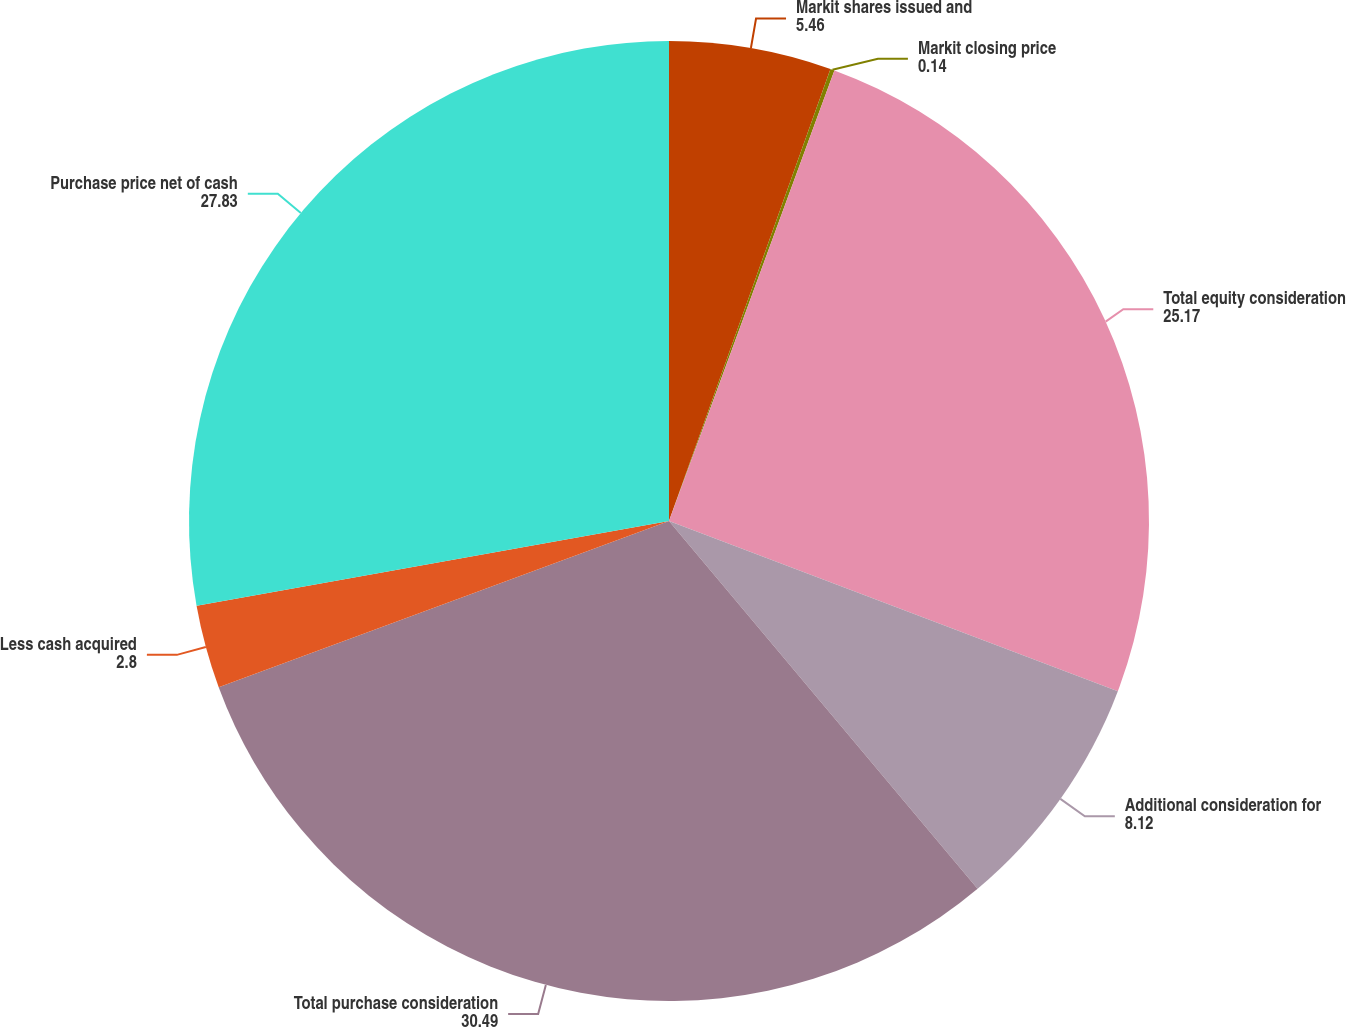Convert chart to OTSL. <chart><loc_0><loc_0><loc_500><loc_500><pie_chart><fcel>Markit shares issued and<fcel>Markit closing price<fcel>Total equity consideration<fcel>Additional consideration for<fcel>Total purchase consideration<fcel>Less cash acquired<fcel>Purchase price net of cash<nl><fcel>5.46%<fcel>0.14%<fcel>25.17%<fcel>8.12%<fcel>30.49%<fcel>2.8%<fcel>27.83%<nl></chart> 